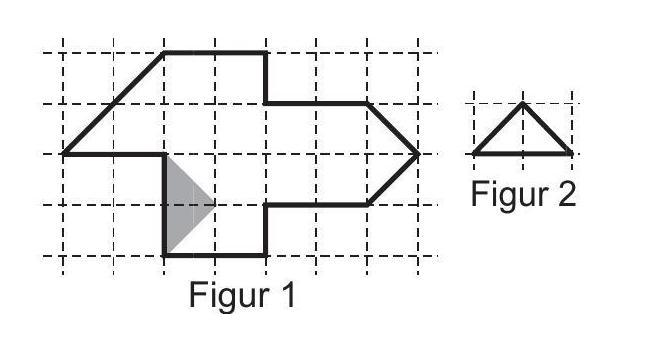Can each triangle be color-coded to highlight different mathematical properties or interior angles? Certainly! Color-coding each triangle can indeed help visualize different properties such as the sizes of angles or the lengths of sides. For instance, using graduated colors to indicate larger or smaller angles can provide visual insights into geometric relations within the shape. 